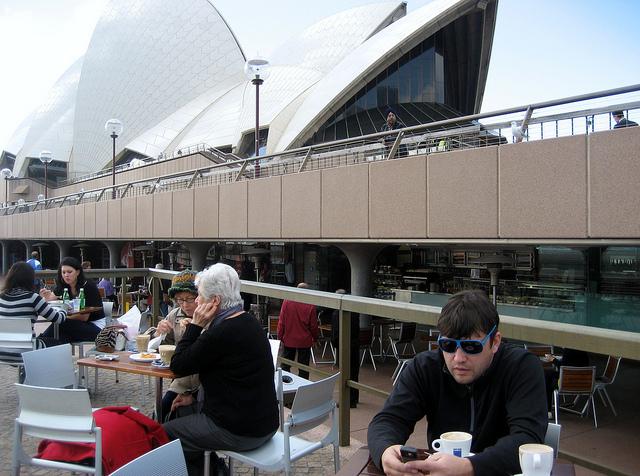Even though the man has dark glasses on, how can you tell he is looking at his phone?
Write a very short answer. Yes. How is the lady with gray hair posture?
Quick response, please. Sitting. Is the man wearing a black shirt?
Quick response, please. Yes. What color is the man wearing?
Quick response, please. Black. 